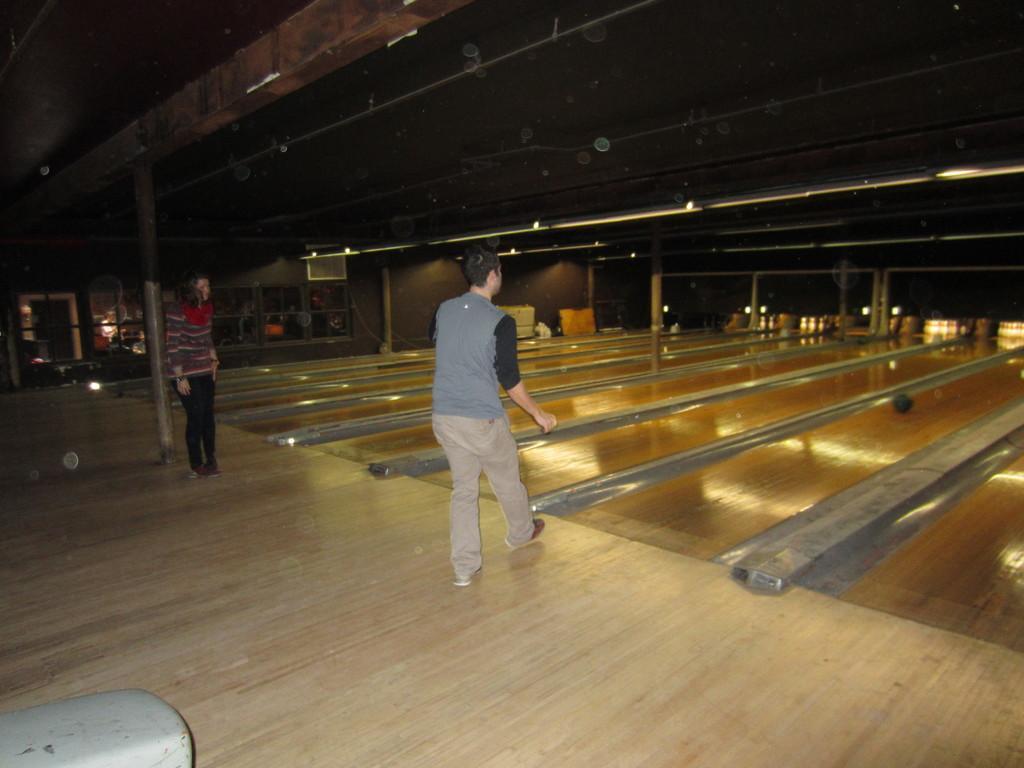Please provide a concise description of this image. In this image in the center there are two persons who are standing and one person is playing something, and on the top of the image there is ceiling and some pillars and poles. In the background there are some doors and lights, at the bottom there is a floor. 